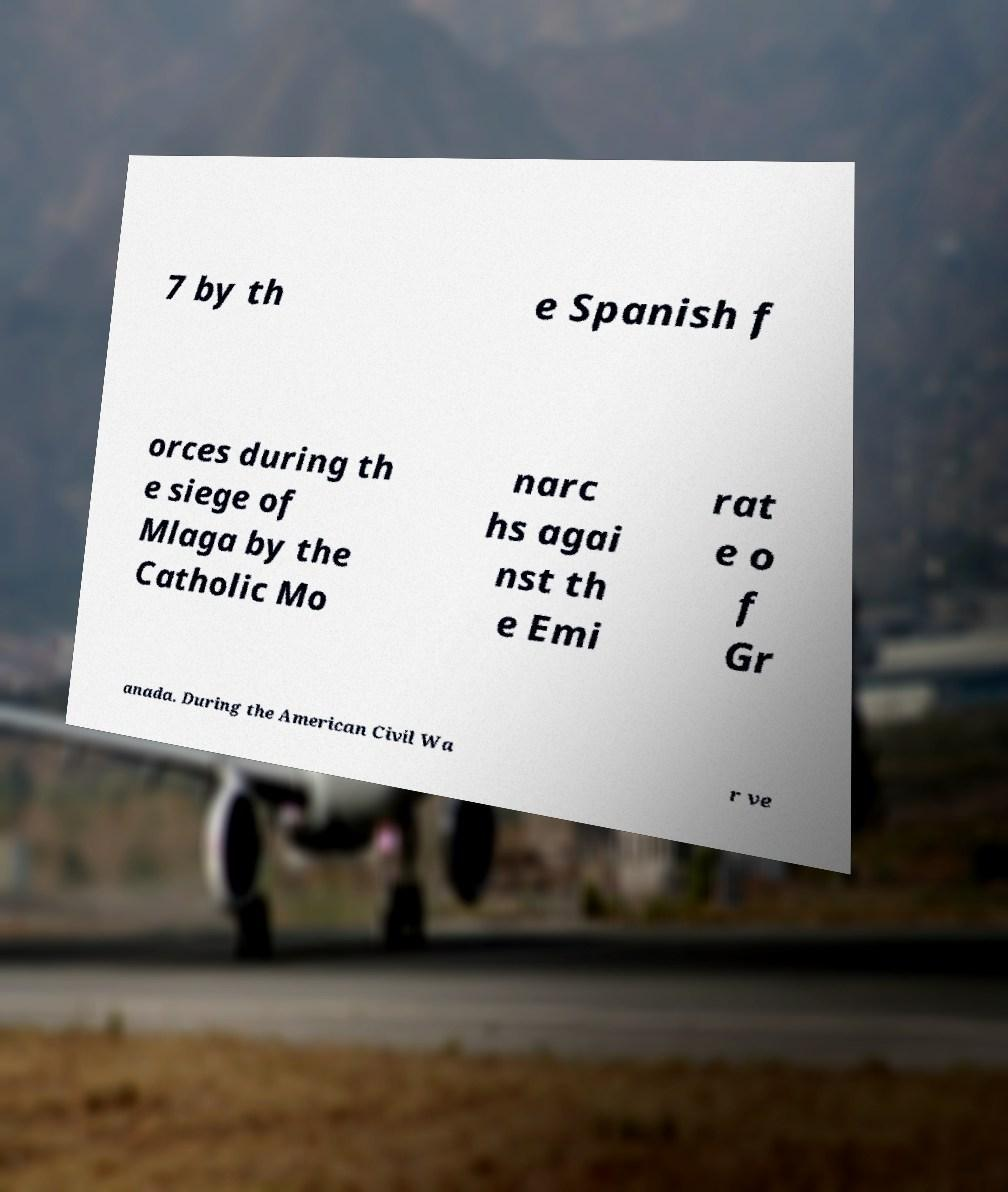Could you assist in decoding the text presented in this image and type it out clearly? 7 by th e Spanish f orces during th e siege of Mlaga by the Catholic Mo narc hs agai nst th e Emi rat e o f Gr anada. During the American Civil Wa r ve 